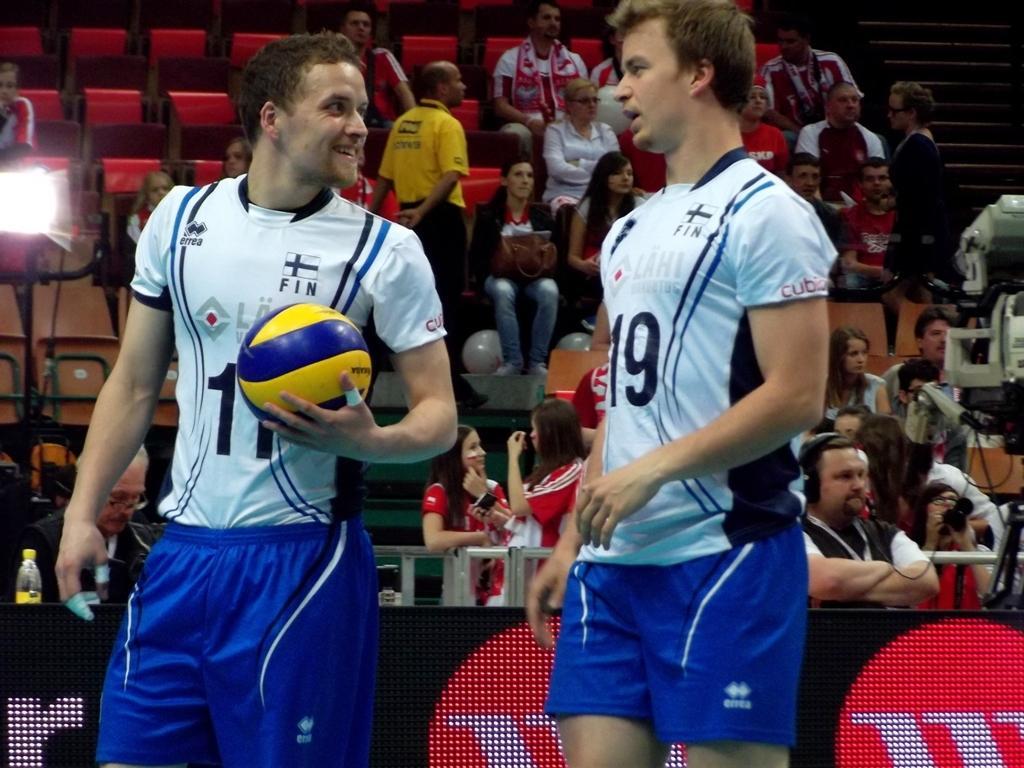Describe this image in one or two sentences. In this picture there are two men standing and one of the guy was holding a ball in his hand. There is a railing in the background and some of them was sitting and some of them was standing in the stands here. 